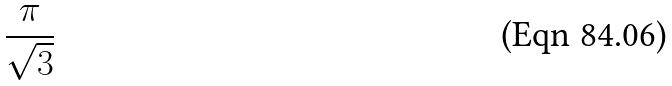Convert formula to latex. <formula><loc_0><loc_0><loc_500><loc_500>\frac { \pi } { \sqrt { 3 } }</formula> 